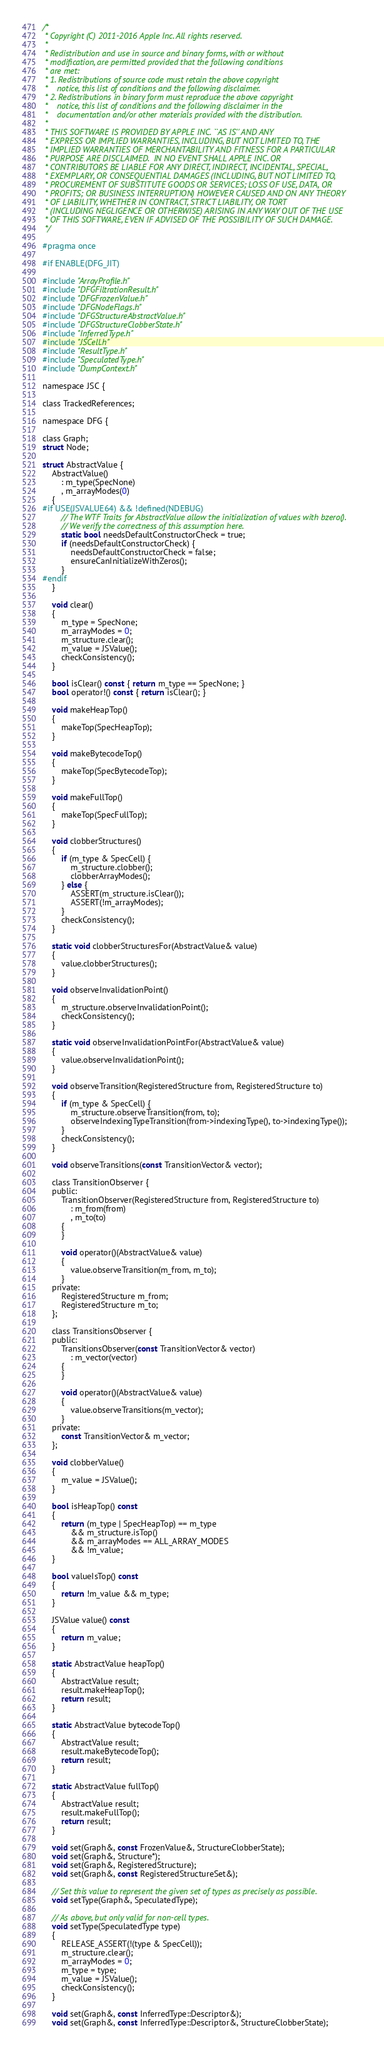Convert code to text. <code><loc_0><loc_0><loc_500><loc_500><_C_>/*
 * Copyright (C) 2011-2016 Apple Inc. All rights reserved.
 *
 * Redistribution and use in source and binary forms, with or without
 * modification, are permitted provided that the following conditions
 * are met:
 * 1. Redistributions of source code must retain the above copyright
 *    notice, this list of conditions and the following disclaimer.
 * 2. Redistributions in binary form must reproduce the above copyright
 *    notice, this list of conditions and the following disclaimer in the
 *    documentation and/or other materials provided with the distribution.
 *
 * THIS SOFTWARE IS PROVIDED BY APPLE INC. ``AS IS'' AND ANY
 * EXPRESS OR IMPLIED WARRANTIES, INCLUDING, BUT NOT LIMITED TO, THE
 * IMPLIED WARRANTIES OF MERCHANTABILITY AND FITNESS FOR A PARTICULAR
 * PURPOSE ARE DISCLAIMED.  IN NO EVENT SHALL APPLE INC. OR
 * CONTRIBUTORS BE LIABLE FOR ANY DIRECT, INDIRECT, INCIDENTAL, SPECIAL,
 * EXEMPLARY, OR CONSEQUENTIAL DAMAGES (INCLUDING, BUT NOT LIMITED TO,
 * PROCUREMENT OF SUBSTITUTE GOODS OR SERVICES; LOSS OF USE, DATA, OR
 * PROFITS; OR BUSINESS INTERRUPTION) HOWEVER CAUSED AND ON ANY THEORY
 * OF LIABILITY, WHETHER IN CONTRACT, STRICT LIABILITY, OR TORT
 * (INCLUDING NEGLIGENCE OR OTHERWISE) ARISING IN ANY WAY OUT OF THE USE
 * OF THIS SOFTWARE, EVEN IF ADVISED OF THE POSSIBILITY OF SUCH DAMAGE. 
 */

#pragma once

#if ENABLE(DFG_JIT)

#include "ArrayProfile.h"
#include "DFGFiltrationResult.h"
#include "DFGFrozenValue.h"
#include "DFGNodeFlags.h"
#include "DFGStructureAbstractValue.h"
#include "DFGStructureClobberState.h"
#include "InferredType.h"
#include "JSCell.h"
#include "ResultType.h"
#include "SpeculatedType.h"
#include "DumpContext.h"

namespace JSC {

class TrackedReferences;

namespace DFG {

class Graph;
struct Node;

struct AbstractValue {
    AbstractValue()
        : m_type(SpecNone)
        , m_arrayModes(0)
    {
#if USE(JSVALUE64) && !defined(NDEBUG)
        // The WTF Traits for AbstractValue allow the initialization of values with bzero().
        // We verify the correctness of this assumption here.
        static bool needsDefaultConstructorCheck = true;
        if (needsDefaultConstructorCheck) {
            needsDefaultConstructorCheck = false;
            ensureCanInitializeWithZeros();
        }
#endif
    }
    
    void clear()
    {
        m_type = SpecNone;
        m_arrayModes = 0;
        m_structure.clear();
        m_value = JSValue();
        checkConsistency();
    }
    
    bool isClear() const { return m_type == SpecNone; }
    bool operator!() const { return isClear(); }
    
    void makeHeapTop()
    {
        makeTop(SpecHeapTop);
    }
    
    void makeBytecodeTop()
    {
        makeTop(SpecBytecodeTop);
    }
    
    void makeFullTop()
    {
        makeTop(SpecFullTop);
    }
    
    void clobberStructures()
    {
        if (m_type & SpecCell) {
            m_structure.clobber();
            clobberArrayModes();
        } else {
            ASSERT(m_structure.isClear());
            ASSERT(!m_arrayModes);
        }
        checkConsistency();
    }
    
    static void clobberStructuresFor(AbstractValue& value)
    {
        value.clobberStructures();
    }
    
    void observeInvalidationPoint()
    {
        m_structure.observeInvalidationPoint();
        checkConsistency();
    }
    
    static void observeInvalidationPointFor(AbstractValue& value)
    {
        value.observeInvalidationPoint();
    }
    
    void observeTransition(RegisteredStructure from, RegisteredStructure to)
    {
        if (m_type & SpecCell) {
            m_structure.observeTransition(from, to);
            observeIndexingTypeTransition(from->indexingType(), to->indexingType());
        }
        checkConsistency();
    }
    
    void observeTransitions(const TransitionVector& vector);
    
    class TransitionObserver {
    public:
        TransitionObserver(RegisteredStructure from, RegisteredStructure to)
            : m_from(from)
            , m_to(to)
        {
        }
        
        void operator()(AbstractValue& value)
        {
            value.observeTransition(m_from, m_to);
        }
    private:
        RegisteredStructure m_from;
        RegisteredStructure m_to;
    };
    
    class TransitionsObserver {
    public:
        TransitionsObserver(const TransitionVector& vector)
            : m_vector(vector)
        {
        }
        
        void operator()(AbstractValue& value)
        {
            value.observeTransitions(m_vector);
        }
    private:
        const TransitionVector& m_vector;
    };
    
    void clobberValue()
    {
        m_value = JSValue();
    }
    
    bool isHeapTop() const
    {
        return (m_type | SpecHeapTop) == m_type
            && m_structure.isTop()
            && m_arrayModes == ALL_ARRAY_MODES
            && !m_value;
    }
    
    bool valueIsTop() const
    {
        return !m_value && m_type;
    }
    
    JSValue value() const
    {
        return m_value;
    }
    
    static AbstractValue heapTop()
    {
        AbstractValue result;
        result.makeHeapTop();
        return result;
    }
    
    static AbstractValue bytecodeTop()
    {
        AbstractValue result;
        result.makeBytecodeTop();
        return result;
    }
    
    static AbstractValue fullTop()
    {
        AbstractValue result;
        result.makeFullTop();
        return result;
    }
    
    void set(Graph&, const FrozenValue&, StructureClobberState);
    void set(Graph&, Structure*);
    void set(Graph&, RegisteredStructure);
    void set(Graph&, const RegisteredStructureSet&);
    
    // Set this value to represent the given set of types as precisely as possible.
    void setType(Graph&, SpeculatedType);
    
    // As above, but only valid for non-cell types.
    void setType(SpeculatedType type)
    {
        RELEASE_ASSERT(!(type & SpecCell));
        m_structure.clear();
        m_arrayModes = 0;
        m_type = type;
        m_value = JSValue();
        checkConsistency();
    }

    void set(Graph&, const InferredType::Descriptor&);
    void set(Graph&, const InferredType::Descriptor&, StructureClobberState);
</code> 